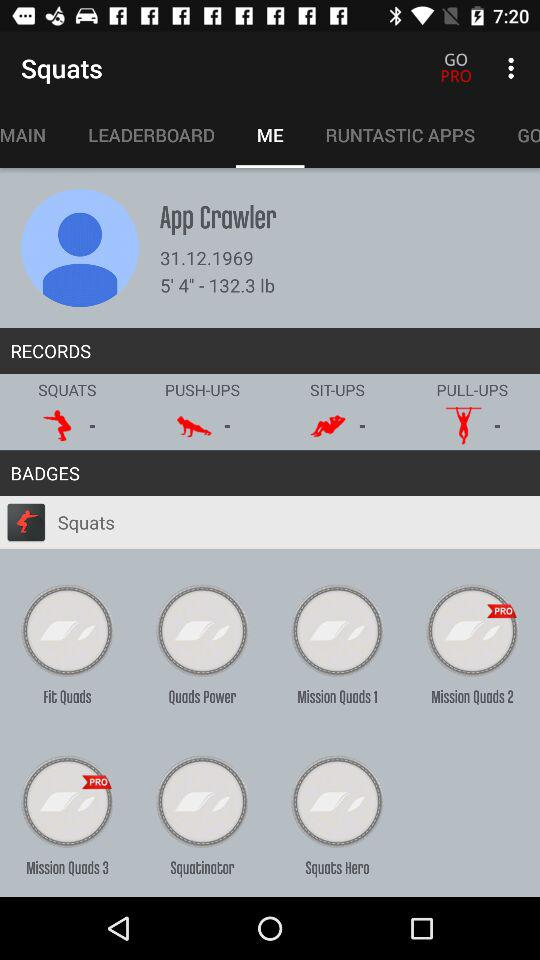What's the weight of the user in pounds? The weight of the user in pounds is 132.3. 